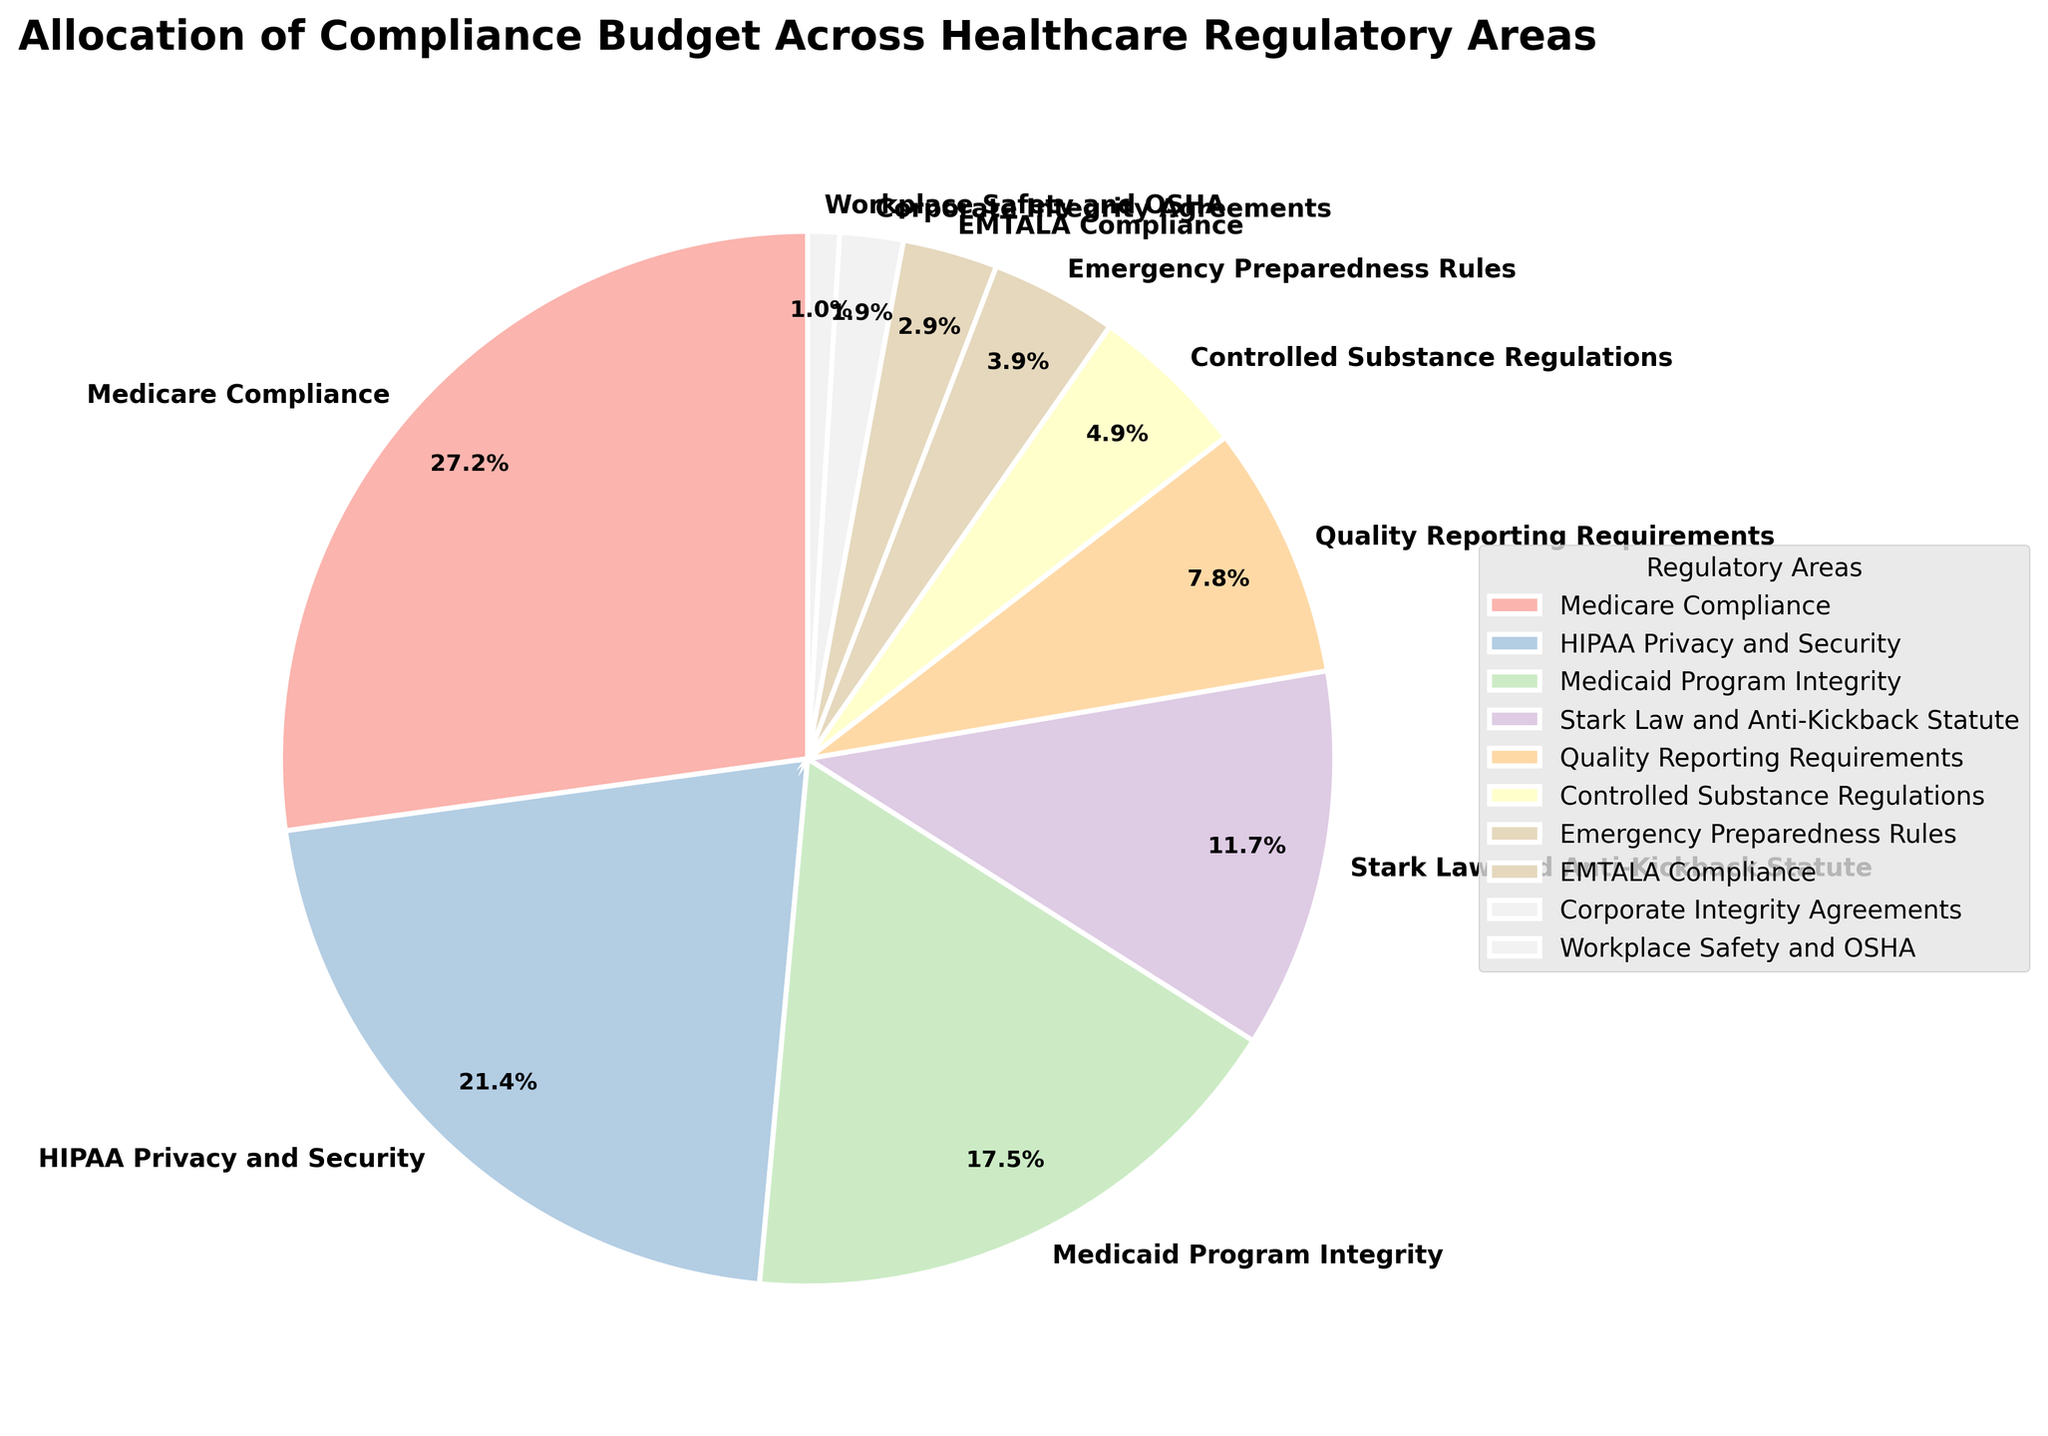Which regulatory area has the highest budget allocation? Identify the largest percentage segment in the pie chart. The largest segment corresponds to Medicare Compliance with 28%.
Answer: Medicare Compliance What is the combined budget allocation for Medicare Compliance and HIPAA Privacy and Security? Find the percentages for Medicare Compliance (28%) and HIPAA Privacy and Security (22%), then add them together: 28% + 22% = 50%
Answer: 50% How much more budget allocation does Medicare Compliance receive compared to Medicaid Program Integrity? Compare the percentages for Medicare Compliance (28%) and Medicaid Program Integrity (18%), then subtract the smaller percentage from the larger one: 28% - 18% = 10%
Answer: 10% Which regulatory areas have budget allocations of less than 5%? Identify segments with percentages less than 5%. These include Emergency Preparedness Rules (4%), EMTALA Compliance (3%), Corporate Integrity Agreements (2%), and Workplace Safety and OSHA (1%).
Answer: Emergency Preparedness Rules, EMTALA Compliance, Corporate Integrity Agreements, Workplace Safety and OSHA What's the average budget allocation for Quality Reporting Requirements, Controlled Substance Regulations, and Emergency Preparedness Rules? Sum the percentages for Quality Reporting Requirements (8%), Controlled Substance Regulations (5%), and Emergency Preparedness Rules (4%), then divide by the number of areas: (8% + 5% + 4%) / 3 = 5.67%
Answer: 5.67% Is HIPAA Privacy and Security allocated more budget than Stark Law and Anti-Kickback Statute? Compare the percentages for HIPAA Privacy and Security (22%) and Stark Law and Anti-Kickback Statute (12%). 22% is greater than 12%.
Answer: Yes Which regulatory area has the smallest budget allocation and by how much? Identify the smallest segment in the pie chart, which is Workplace Safety and OSHA with 1%.
Answer: Workplace Safety and OSHA How does the budget allocation for Controlled Substance Regulations compare to the sum of Corporate Integrity Agreements and EMTALA Compliance? Compare the percentage for Controlled Substance Regulations (5%) with the combined percentages of Corporate Integrity Agreements (2%) and EMTALA Compliance (3%): 5% vs (2% + 3%) = 5%. Both are equal.
Answer: Equal What's the total budget allocation percentage for non-Medicare/Medicaid related areas (excluding Medicare Compliance and Medicaid Program Integrity)? Sum the percentages of all areas excluding Medicare Compliance (28%) and Medicaid Program Integrity (18%): 100% - (28% + 18%) = 54%
Answer: 54% Which regulatory areas together make up more than half of the total budget allocation? Identify the largest percentages until their sum exceeds 50%. Medicare Compliance (28%) and HIPAA Privacy and Security (22%) together make 50%, therefore, adding any other area will exceed 50%.
Answer: Medicare Compliance, HIPAA Privacy and Security 